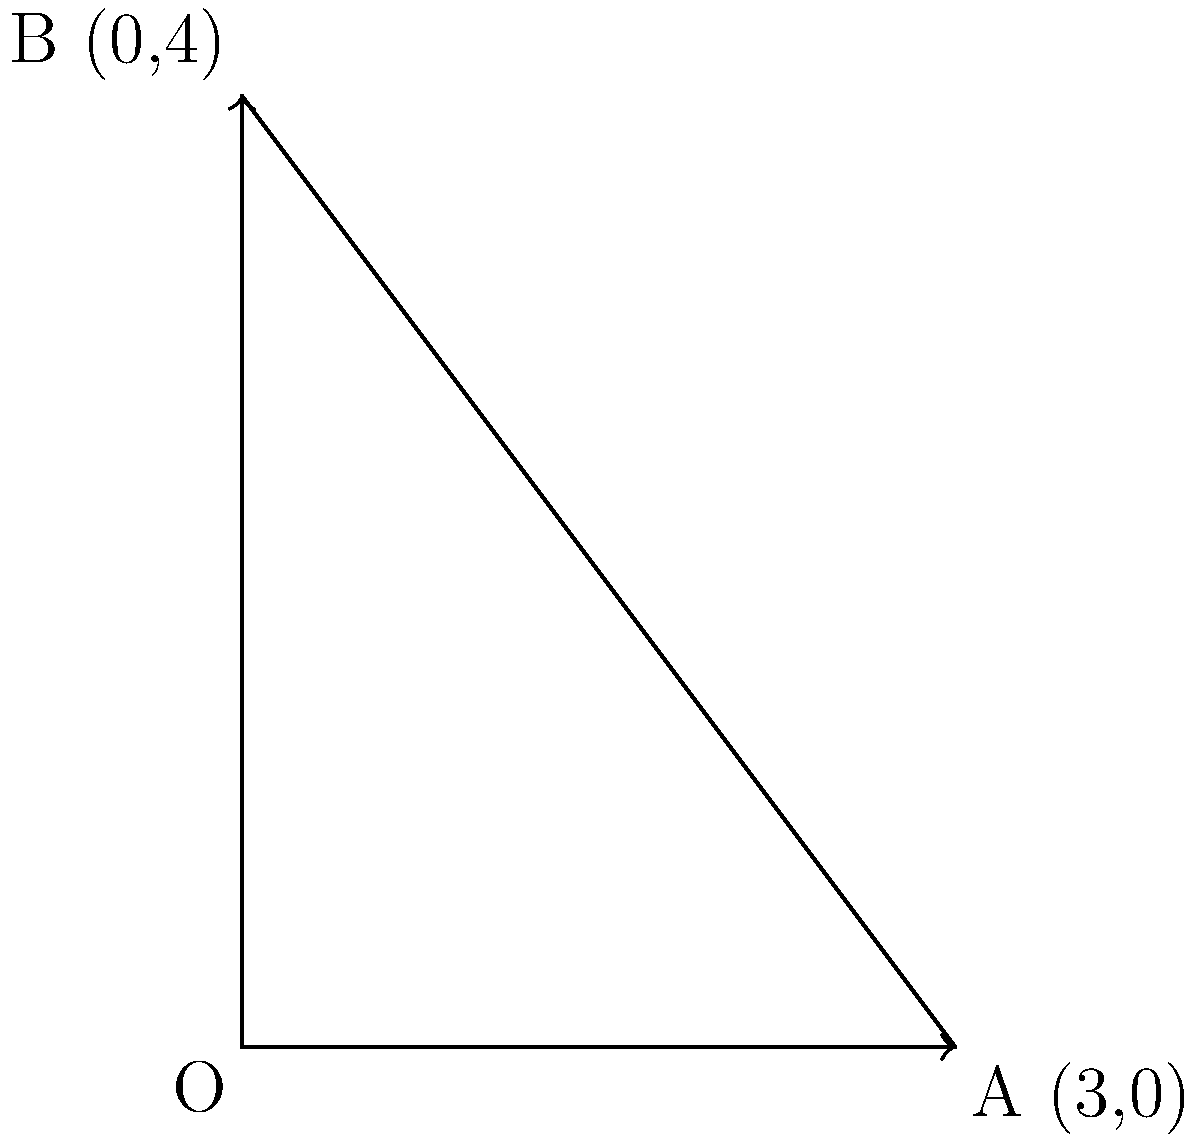As a biology student studying the effects of urban green spaces on mental health, you're analyzing the spread of green areas in a city. The vector from the origin O to point A represents the east-west spread, while the vector from O to B represents the north-south spread of green spaces. If A has coordinates (3,0) and B has coordinates (0,4), what is the magnitude of the resultant vector representing the overall spread of green spaces in the city? To find the magnitude of the resultant vector, we can follow these steps:

1. Identify the components of the resultant vector:
   The east-west component (x) is 3, and the north-south component (y) is 4.

2. Use the Pythagorean theorem to calculate the magnitude:
   The magnitude is given by $$\sqrt{x^2 + y^2}$$

3. Substitute the values:
   $$\sqrt{3^2 + 4^2}$$

4. Simplify:
   $$\sqrt{9 + 16} = \sqrt{25}$$

5. Calculate the final result:
   $$\sqrt{25} = 5$$

Therefore, the magnitude of the resultant vector representing the overall spread of green spaces in the city is 5 units.
Answer: 5 units 